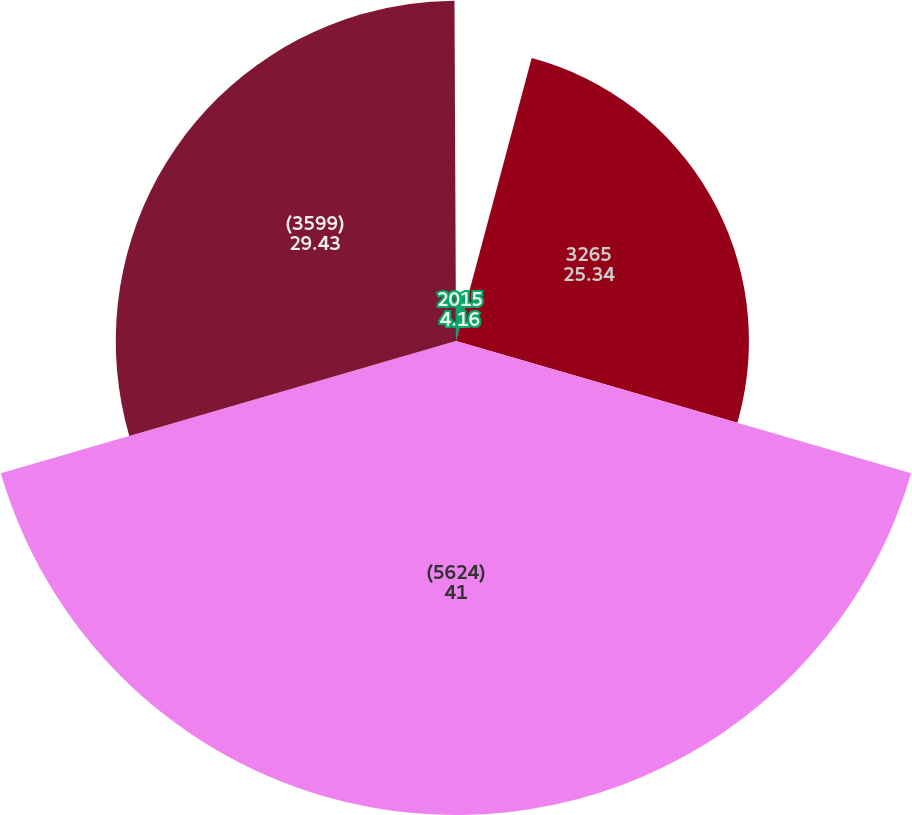Convert chart. <chart><loc_0><loc_0><loc_500><loc_500><pie_chart><fcel>2015<fcel>3265<fcel>(5624)<fcel>(3599)<fcel>(888)<nl><fcel>4.16%<fcel>25.34%<fcel>41.0%<fcel>29.43%<fcel>0.07%<nl></chart> 